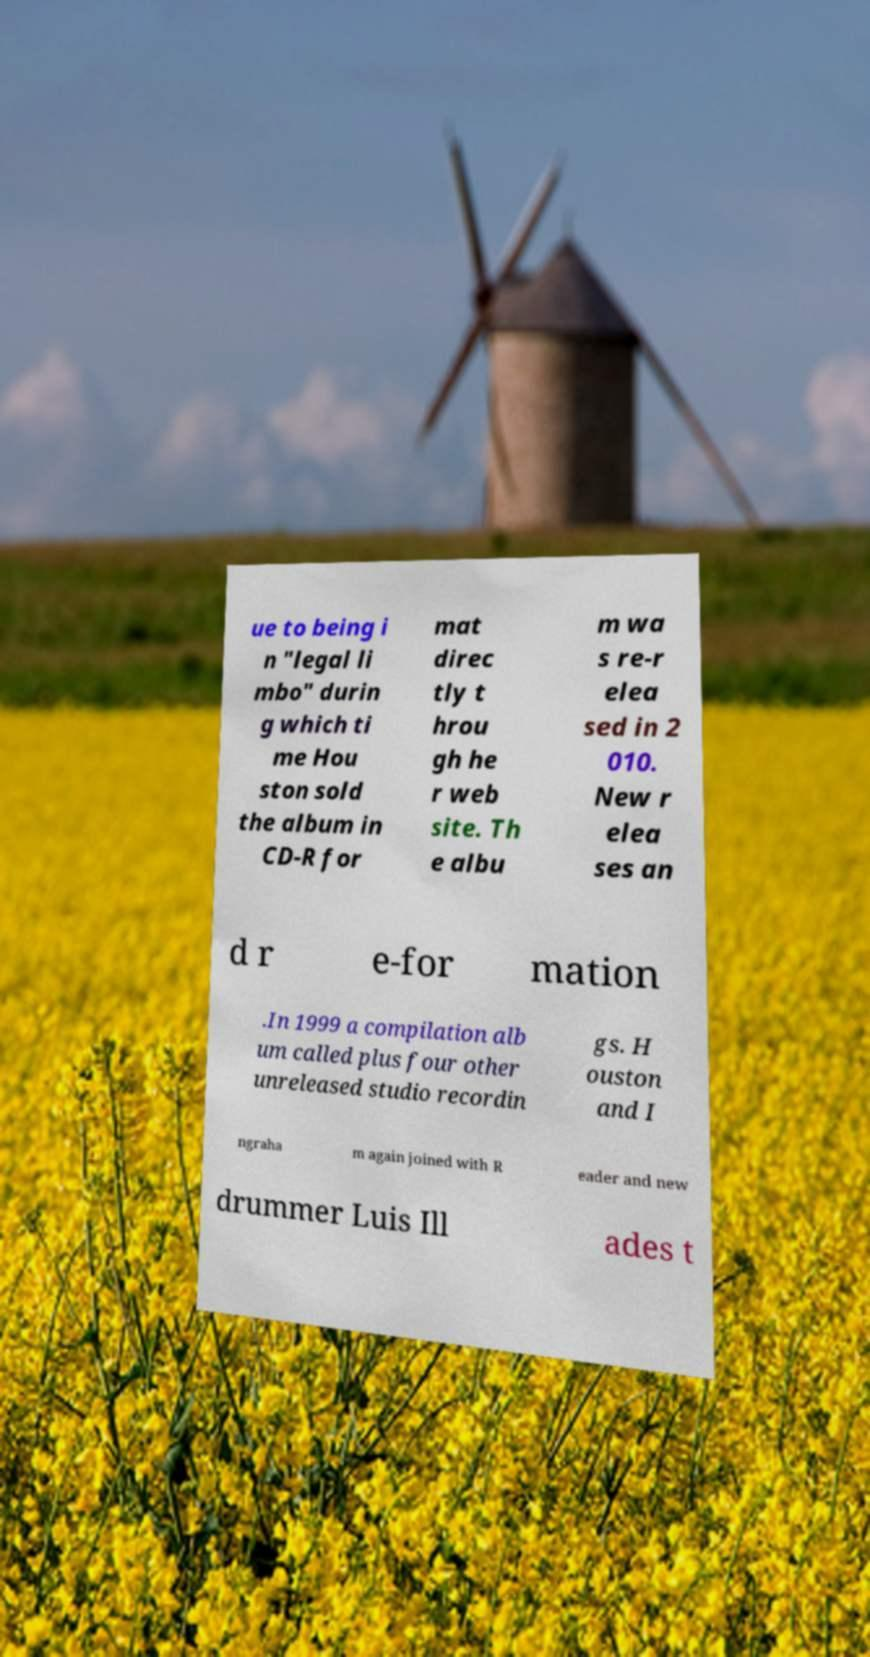There's text embedded in this image that I need extracted. Can you transcribe it verbatim? ue to being i n "legal li mbo" durin g which ti me Hou ston sold the album in CD-R for mat direc tly t hrou gh he r web site. Th e albu m wa s re-r elea sed in 2 010. New r elea ses an d r e-for mation .In 1999 a compilation alb um called plus four other unreleased studio recordin gs. H ouston and I ngraha m again joined with R eader and new drummer Luis Ill ades t 